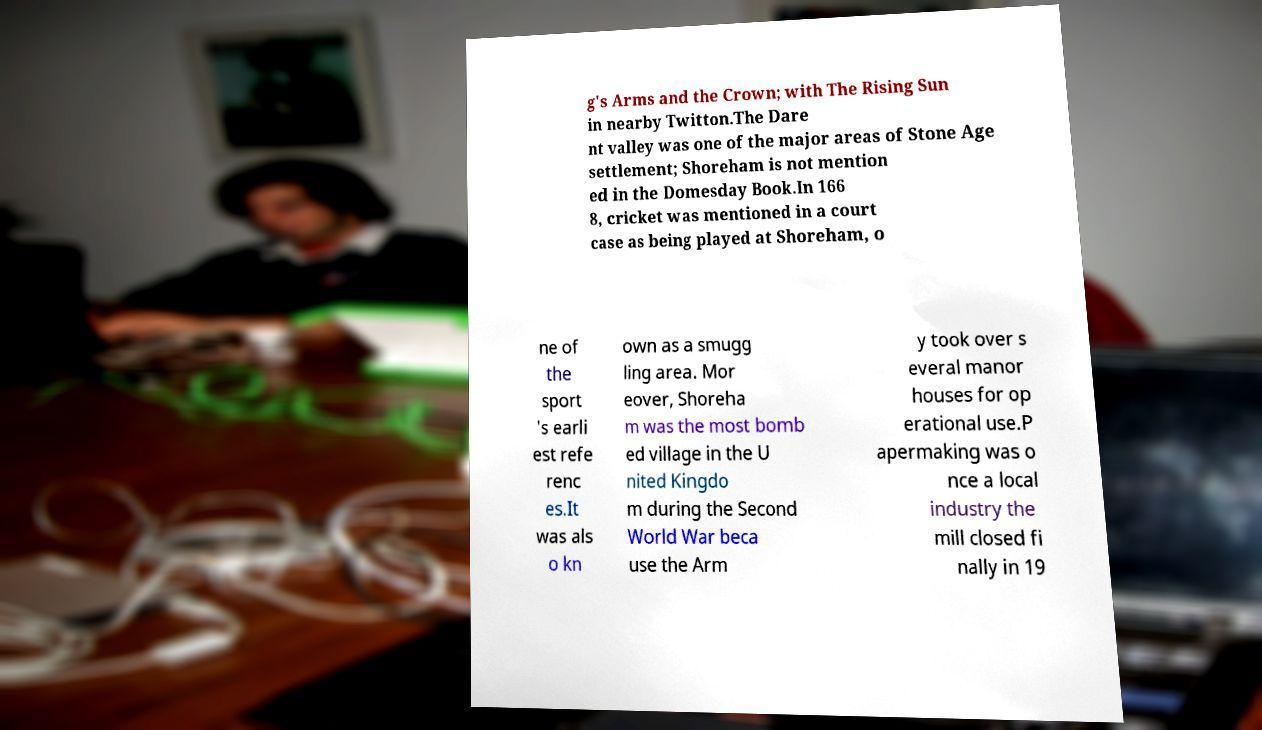I need the written content from this picture converted into text. Can you do that? g's Arms and the Crown; with The Rising Sun in nearby Twitton.The Dare nt valley was one of the major areas of Stone Age settlement; Shoreham is not mention ed in the Domesday Book.In 166 8, cricket was mentioned in a court case as being played at Shoreham, o ne of the sport 's earli est refe renc es.It was als o kn own as a smugg ling area. Mor eover, Shoreha m was the most bomb ed village in the U nited Kingdo m during the Second World War beca use the Arm y took over s everal manor houses for op erational use.P apermaking was o nce a local industry the mill closed fi nally in 19 